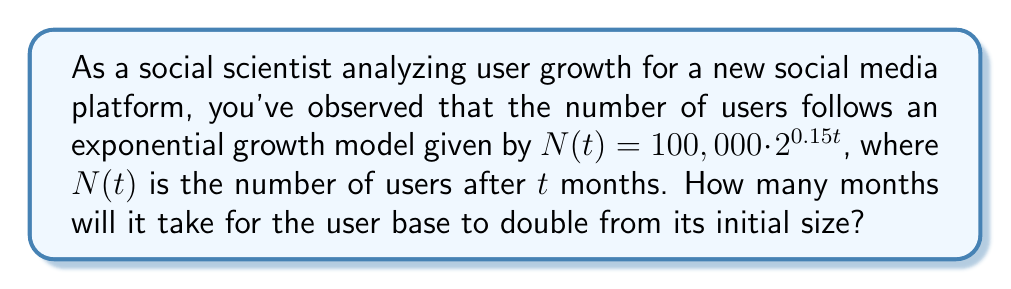Can you answer this question? To solve this problem, we'll use logarithmic equations. Let's approach this step-by-step:

1) We want to find $t$ when $N(t)$ is twice the initial number of users.
   Initial users: $100,000$
   Target users: $200,000$

2) Set up the equation:
   $200,000 = 100,000 \cdot 2^{0.15t}$

3) Simplify:
   $2 = 2^{0.15t}$

4) Take the logarithm (base 2) of both sides:
   $\log_2(2) = \log_2(2^{0.15t})$

5) Simplify the left side:
   $1 = 0.15t \cdot \log_2(2)$

6) Since $\log_2(2) = 1$, we have:
   $1 = 0.15t$

7) Solve for $t$:
   $t = \frac{1}{0.15} \approx 6.67$

Therefore, it will take approximately 6.67 months for the user base to double.
Answer: $\frac{1}{0.15} \approx 6.67$ months 